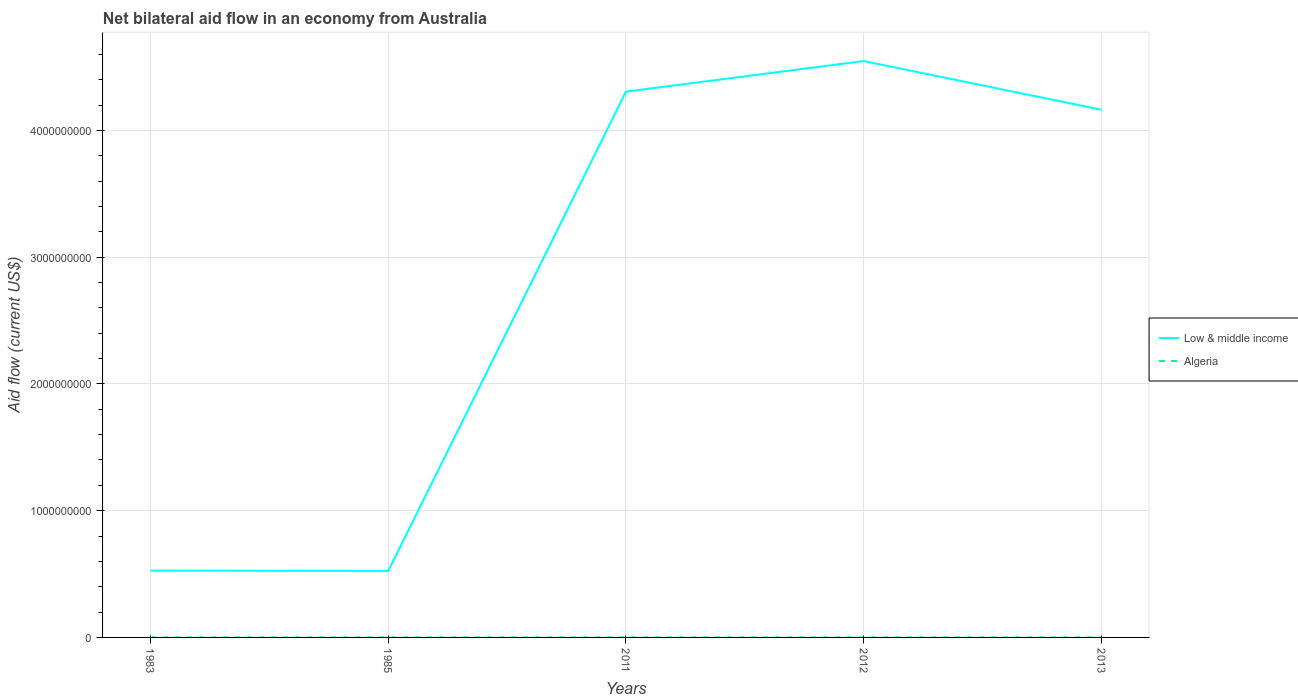In which year was the net bilateral aid flow in Low & middle income maximum?
Your answer should be very brief. 1985. What is the total net bilateral aid flow in Low & middle income in the graph?
Make the answer very short. -3.64e+09. What is the difference between the highest and the second highest net bilateral aid flow in Low & middle income?
Make the answer very short. 4.02e+09. How many lines are there?
Your response must be concise. 2. What is the difference between two consecutive major ticks on the Y-axis?
Give a very brief answer. 1.00e+09. Does the graph contain any zero values?
Your answer should be compact. No. Does the graph contain grids?
Provide a short and direct response. Yes. Where does the legend appear in the graph?
Ensure brevity in your answer.  Center right. What is the title of the graph?
Offer a very short reply. Net bilateral aid flow in an economy from Australia. What is the Aid flow (current US$) in Low & middle income in 1983?
Your response must be concise. 5.27e+08. What is the Aid flow (current US$) of Low & middle income in 1985?
Offer a terse response. 5.25e+08. What is the Aid flow (current US$) in Low & middle income in 2011?
Give a very brief answer. 4.31e+09. What is the Aid flow (current US$) in Low & middle income in 2012?
Your answer should be very brief. 4.55e+09. What is the Aid flow (current US$) in Low & middle income in 2013?
Make the answer very short. 4.16e+09. What is the Aid flow (current US$) in Algeria in 2013?
Make the answer very short. 7.00e+04. Across all years, what is the maximum Aid flow (current US$) in Low & middle income?
Provide a short and direct response. 4.55e+09. Across all years, what is the minimum Aid flow (current US$) in Low & middle income?
Offer a terse response. 5.25e+08. Across all years, what is the minimum Aid flow (current US$) in Algeria?
Your answer should be very brief. 3.00e+04. What is the total Aid flow (current US$) in Low & middle income in the graph?
Keep it short and to the point. 1.41e+1. What is the difference between the Aid flow (current US$) in Low & middle income in 1983 and that in 1985?
Give a very brief answer. 2.60e+06. What is the difference between the Aid flow (current US$) in Low & middle income in 1983 and that in 2011?
Your answer should be very brief. -3.78e+09. What is the difference between the Aid flow (current US$) in Algeria in 1983 and that in 2011?
Provide a succinct answer. -4.00e+04. What is the difference between the Aid flow (current US$) of Low & middle income in 1983 and that in 2012?
Your answer should be compact. -4.02e+09. What is the difference between the Aid flow (current US$) in Low & middle income in 1983 and that in 2013?
Your answer should be very brief. -3.64e+09. What is the difference between the Aid flow (current US$) in Low & middle income in 1985 and that in 2011?
Your response must be concise. -3.78e+09. What is the difference between the Aid flow (current US$) of Algeria in 1985 and that in 2011?
Provide a succinct answer. -2.00e+04. What is the difference between the Aid flow (current US$) in Low & middle income in 1985 and that in 2012?
Provide a short and direct response. -4.02e+09. What is the difference between the Aid flow (current US$) in Algeria in 1985 and that in 2012?
Provide a succinct answer. -10000. What is the difference between the Aid flow (current US$) of Low & middle income in 1985 and that in 2013?
Keep it short and to the point. -3.64e+09. What is the difference between the Aid flow (current US$) in Algeria in 1985 and that in 2013?
Ensure brevity in your answer.  -2.00e+04. What is the difference between the Aid flow (current US$) in Low & middle income in 2011 and that in 2012?
Make the answer very short. -2.41e+08. What is the difference between the Aid flow (current US$) in Low & middle income in 2011 and that in 2013?
Provide a short and direct response. 1.43e+08. What is the difference between the Aid flow (current US$) in Algeria in 2011 and that in 2013?
Provide a short and direct response. 0. What is the difference between the Aid flow (current US$) in Low & middle income in 2012 and that in 2013?
Provide a short and direct response. 3.84e+08. What is the difference between the Aid flow (current US$) in Algeria in 2012 and that in 2013?
Keep it short and to the point. -10000. What is the difference between the Aid flow (current US$) in Low & middle income in 1983 and the Aid flow (current US$) in Algeria in 1985?
Ensure brevity in your answer.  5.27e+08. What is the difference between the Aid flow (current US$) of Low & middle income in 1983 and the Aid flow (current US$) of Algeria in 2011?
Offer a very short reply. 5.27e+08. What is the difference between the Aid flow (current US$) in Low & middle income in 1983 and the Aid flow (current US$) in Algeria in 2012?
Keep it short and to the point. 5.27e+08. What is the difference between the Aid flow (current US$) in Low & middle income in 1983 and the Aid flow (current US$) in Algeria in 2013?
Your answer should be compact. 5.27e+08. What is the difference between the Aid flow (current US$) in Low & middle income in 1985 and the Aid flow (current US$) in Algeria in 2011?
Your response must be concise. 5.25e+08. What is the difference between the Aid flow (current US$) in Low & middle income in 1985 and the Aid flow (current US$) in Algeria in 2012?
Your answer should be compact. 5.25e+08. What is the difference between the Aid flow (current US$) of Low & middle income in 1985 and the Aid flow (current US$) of Algeria in 2013?
Your answer should be very brief. 5.25e+08. What is the difference between the Aid flow (current US$) of Low & middle income in 2011 and the Aid flow (current US$) of Algeria in 2012?
Your answer should be very brief. 4.31e+09. What is the difference between the Aid flow (current US$) of Low & middle income in 2011 and the Aid flow (current US$) of Algeria in 2013?
Provide a succinct answer. 4.31e+09. What is the difference between the Aid flow (current US$) of Low & middle income in 2012 and the Aid flow (current US$) of Algeria in 2013?
Your answer should be very brief. 4.55e+09. What is the average Aid flow (current US$) in Low & middle income per year?
Provide a short and direct response. 2.81e+09. What is the average Aid flow (current US$) of Algeria per year?
Offer a terse response. 5.60e+04. In the year 1983, what is the difference between the Aid flow (current US$) of Low & middle income and Aid flow (current US$) of Algeria?
Keep it short and to the point. 5.27e+08. In the year 1985, what is the difference between the Aid flow (current US$) in Low & middle income and Aid flow (current US$) in Algeria?
Ensure brevity in your answer.  5.25e+08. In the year 2011, what is the difference between the Aid flow (current US$) in Low & middle income and Aid flow (current US$) in Algeria?
Provide a succinct answer. 4.31e+09. In the year 2012, what is the difference between the Aid flow (current US$) in Low & middle income and Aid flow (current US$) in Algeria?
Offer a terse response. 4.55e+09. In the year 2013, what is the difference between the Aid flow (current US$) in Low & middle income and Aid flow (current US$) in Algeria?
Your response must be concise. 4.16e+09. What is the ratio of the Aid flow (current US$) of Algeria in 1983 to that in 1985?
Offer a terse response. 0.6. What is the ratio of the Aid flow (current US$) of Low & middle income in 1983 to that in 2011?
Provide a short and direct response. 0.12. What is the ratio of the Aid flow (current US$) of Algeria in 1983 to that in 2011?
Provide a short and direct response. 0.43. What is the ratio of the Aid flow (current US$) in Low & middle income in 1983 to that in 2012?
Offer a very short reply. 0.12. What is the ratio of the Aid flow (current US$) of Algeria in 1983 to that in 2012?
Give a very brief answer. 0.5. What is the ratio of the Aid flow (current US$) of Low & middle income in 1983 to that in 2013?
Keep it short and to the point. 0.13. What is the ratio of the Aid flow (current US$) of Algeria in 1983 to that in 2013?
Make the answer very short. 0.43. What is the ratio of the Aid flow (current US$) of Low & middle income in 1985 to that in 2011?
Your answer should be very brief. 0.12. What is the ratio of the Aid flow (current US$) of Low & middle income in 1985 to that in 2012?
Your response must be concise. 0.12. What is the ratio of the Aid flow (current US$) in Algeria in 1985 to that in 2012?
Your answer should be compact. 0.83. What is the ratio of the Aid flow (current US$) of Low & middle income in 1985 to that in 2013?
Offer a terse response. 0.13. What is the ratio of the Aid flow (current US$) in Algeria in 1985 to that in 2013?
Offer a very short reply. 0.71. What is the ratio of the Aid flow (current US$) of Low & middle income in 2011 to that in 2012?
Your answer should be compact. 0.95. What is the ratio of the Aid flow (current US$) of Algeria in 2011 to that in 2012?
Offer a very short reply. 1.17. What is the ratio of the Aid flow (current US$) in Low & middle income in 2011 to that in 2013?
Your answer should be compact. 1.03. What is the ratio of the Aid flow (current US$) of Low & middle income in 2012 to that in 2013?
Your answer should be compact. 1.09. What is the ratio of the Aid flow (current US$) in Algeria in 2012 to that in 2013?
Provide a succinct answer. 0.86. What is the difference between the highest and the second highest Aid flow (current US$) in Low & middle income?
Offer a terse response. 2.41e+08. What is the difference between the highest and the second highest Aid flow (current US$) of Algeria?
Give a very brief answer. 0. What is the difference between the highest and the lowest Aid flow (current US$) in Low & middle income?
Your answer should be compact. 4.02e+09. What is the difference between the highest and the lowest Aid flow (current US$) of Algeria?
Provide a short and direct response. 4.00e+04. 